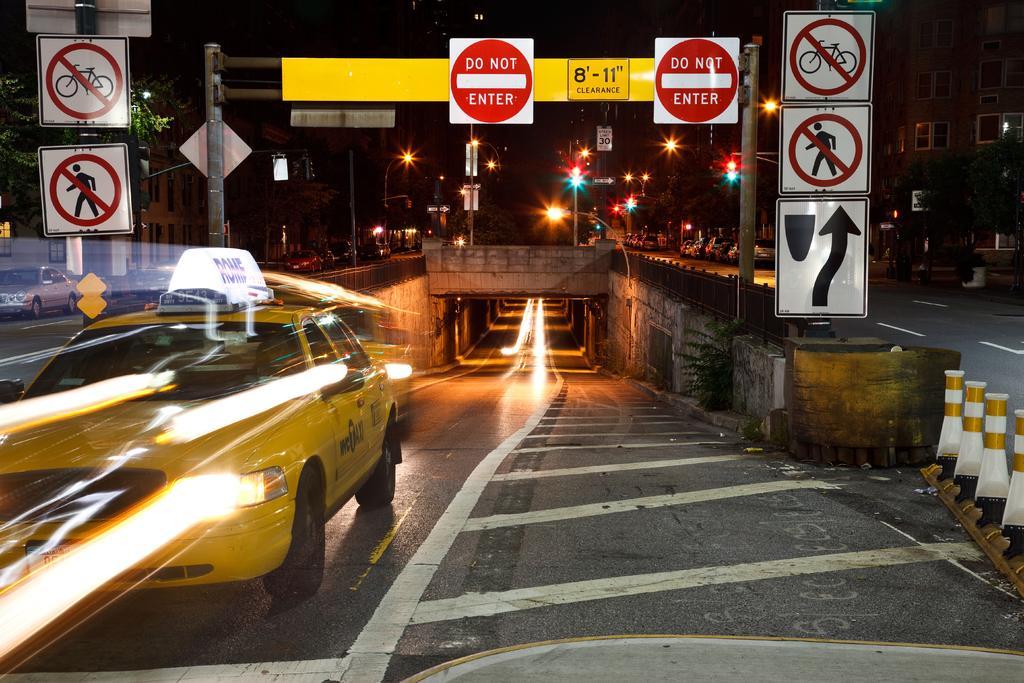In one or two sentences, can you explain what this image depicts? In this image there are buildings, trees, sign boards, vehicles, poles with lights and there is a metal fence on the left and right corner. There is a road at the bottom. There are vehicles, and there is an underpass road in the foreground. There are poles with lights and it is dark in the background. 